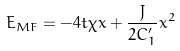Convert formula to latex. <formula><loc_0><loc_0><loc_500><loc_500>E _ { M F } = - 4 t \chi x + \frac { J } { 2 C _ { 1 } ^ { \prime } } x ^ { 2 }</formula> 